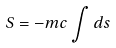Convert formula to latex. <formula><loc_0><loc_0><loc_500><loc_500>S = - m c \int d s</formula> 